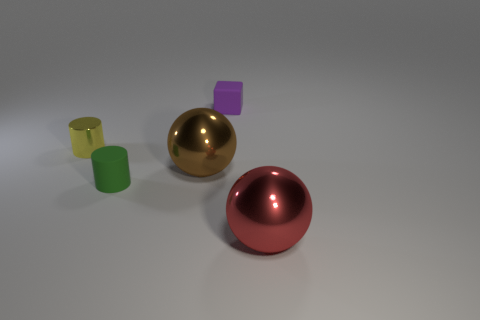There is a green cylinder that is behind the sphere that is on the right side of the tiny purple object; what is it made of?
Your answer should be compact. Rubber. Is there a tiny yellow metal thing that has the same shape as the green rubber object?
Your answer should be very brief. Yes. What is the shape of the red object?
Offer a terse response. Sphere. There is a small object to the right of the large thing left of the rubber thing behind the tiny yellow thing; what is its material?
Offer a terse response. Rubber. Are there more shiny things right of the purple thing than big yellow spheres?
Offer a terse response. Yes. There is a yellow cylinder that is the same size as the purple rubber thing; what material is it?
Your answer should be very brief. Metal. Is there a ball of the same size as the brown metal object?
Give a very brief answer. Yes. What size is the brown shiny thing on the left side of the small purple matte object?
Make the answer very short. Large. What is the size of the purple matte cube?
Offer a very short reply. Small. What number of cylinders are either green objects or red shiny things?
Ensure brevity in your answer.  1. 